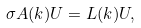Convert formula to latex. <formula><loc_0><loc_0><loc_500><loc_500>\sigma A ( k ) U = L ( k ) U ,</formula> 